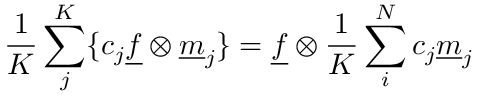<formula> <loc_0><loc_0><loc_500><loc_500>\frac { 1 } { K } \sum _ { j } ^ { K } \{ c _ { j } \underline { f } \otimes \underline { m } _ { j } \} = \underline { f } \otimes \frac { 1 } { K } \sum _ { i } ^ { N } c _ { j } \underline { m } _ { j }</formula> 